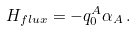Convert formula to latex. <formula><loc_0><loc_0><loc_500><loc_500>H _ { f l u x } = - q _ { 0 } ^ { A } \alpha _ { A } \, .</formula> 